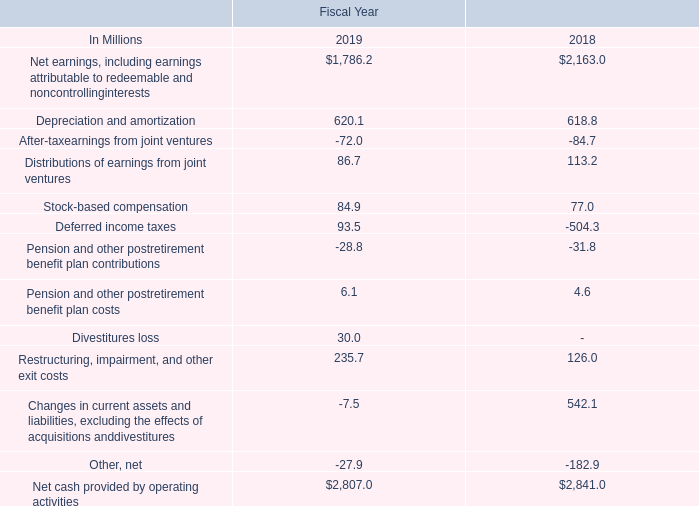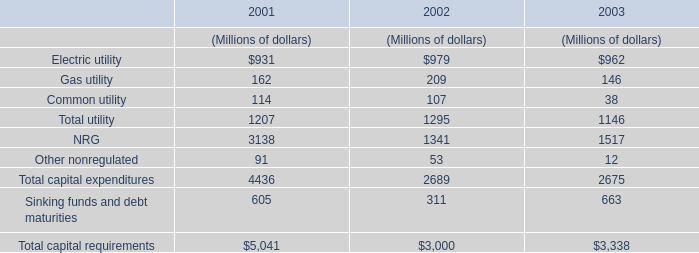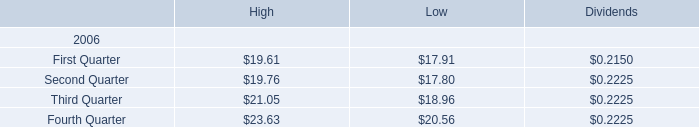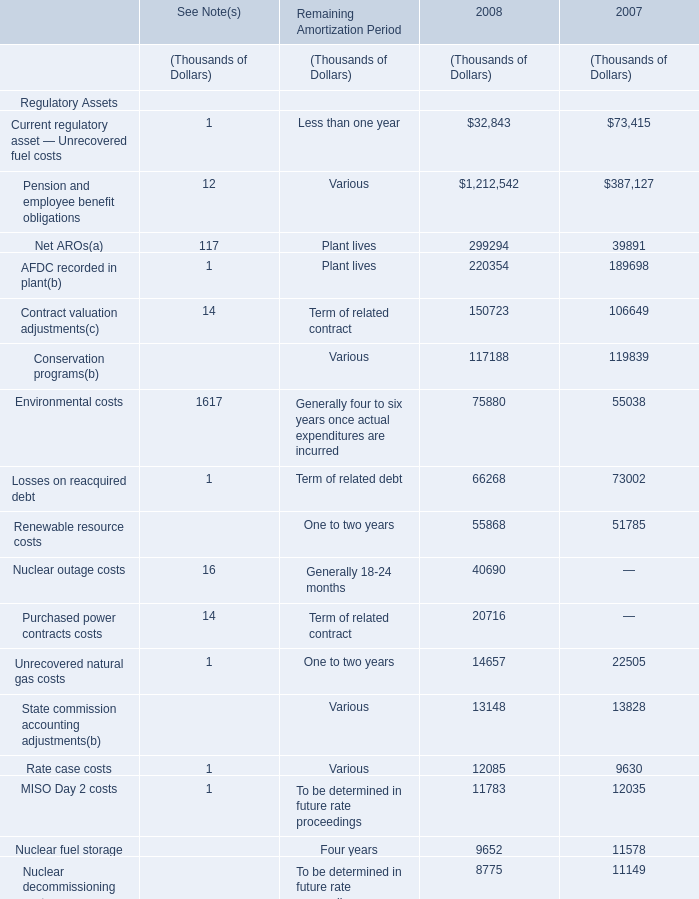What is the proportion of Environmental costs to the total non current regulatory assets in 2008? 
Computations: (75880 / 2357279)
Answer: 0.03219. 